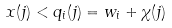<formula> <loc_0><loc_0><loc_500><loc_500>x ( j ) < q _ { i } ( j ) = w _ { i } + \chi ( j )</formula> 